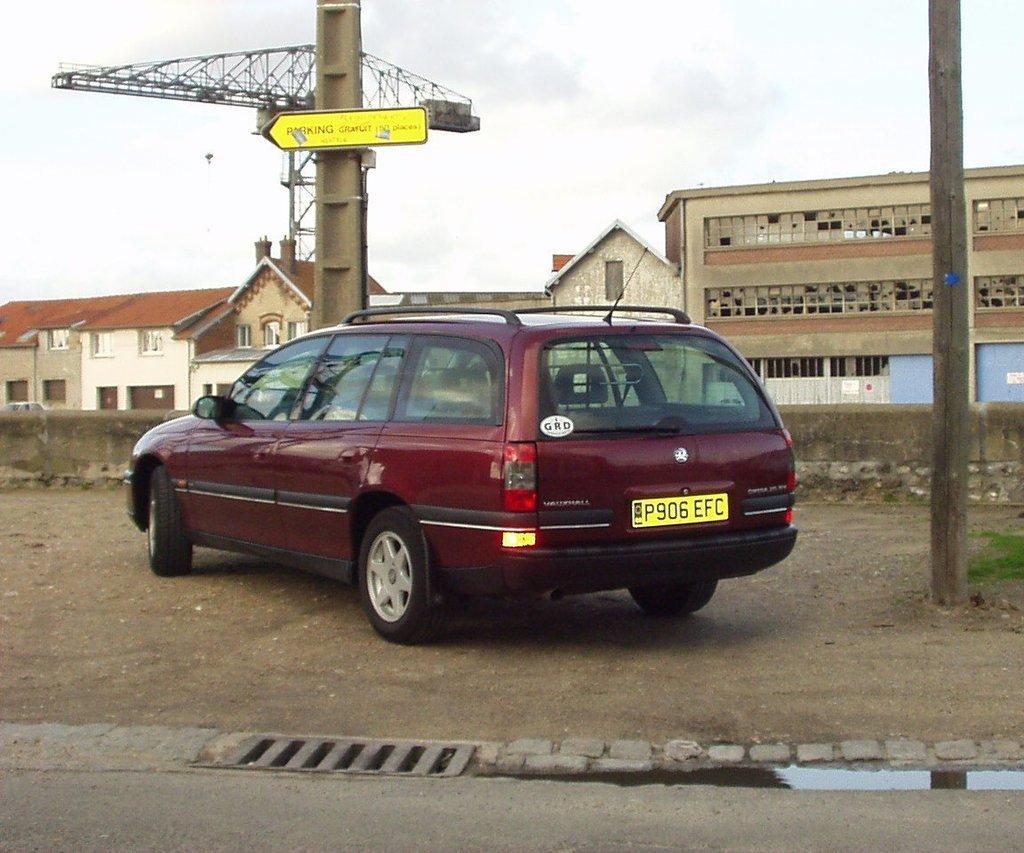In one or two sentences, can you explain what this image depicts? In this picture there is a vehicle which is in red in color. It is facing towards the left. At the bottom there is a road. Towards the right there is a pole. Before the vehicle there is a pillar with a crane. In the background there are buildings and a sky. 